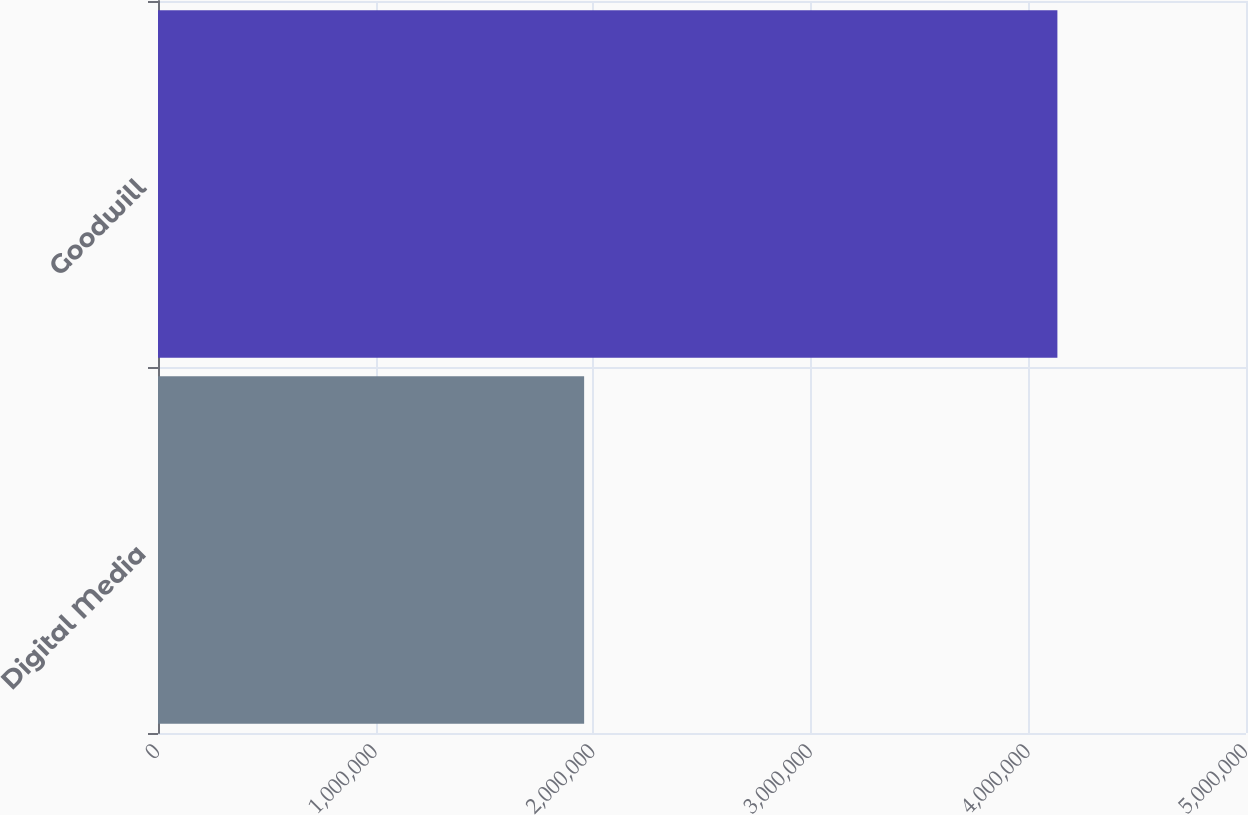<chart> <loc_0><loc_0><loc_500><loc_500><bar_chart><fcel>Digital Media<fcel>Goodwill<nl><fcel>1.95833e+06<fcel>4.13326e+06<nl></chart> 